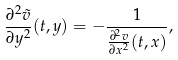<formula> <loc_0><loc_0><loc_500><loc_500>\frac { \partial ^ { 2 } \tilde { v } } { \partial y ^ { 2 } } ( t , y ) = - \frac { 1 } { \frac { \partial ^ { 2 } { v } } { \partial x ^ { 2 } } ( t , x ) } ,</formula> 